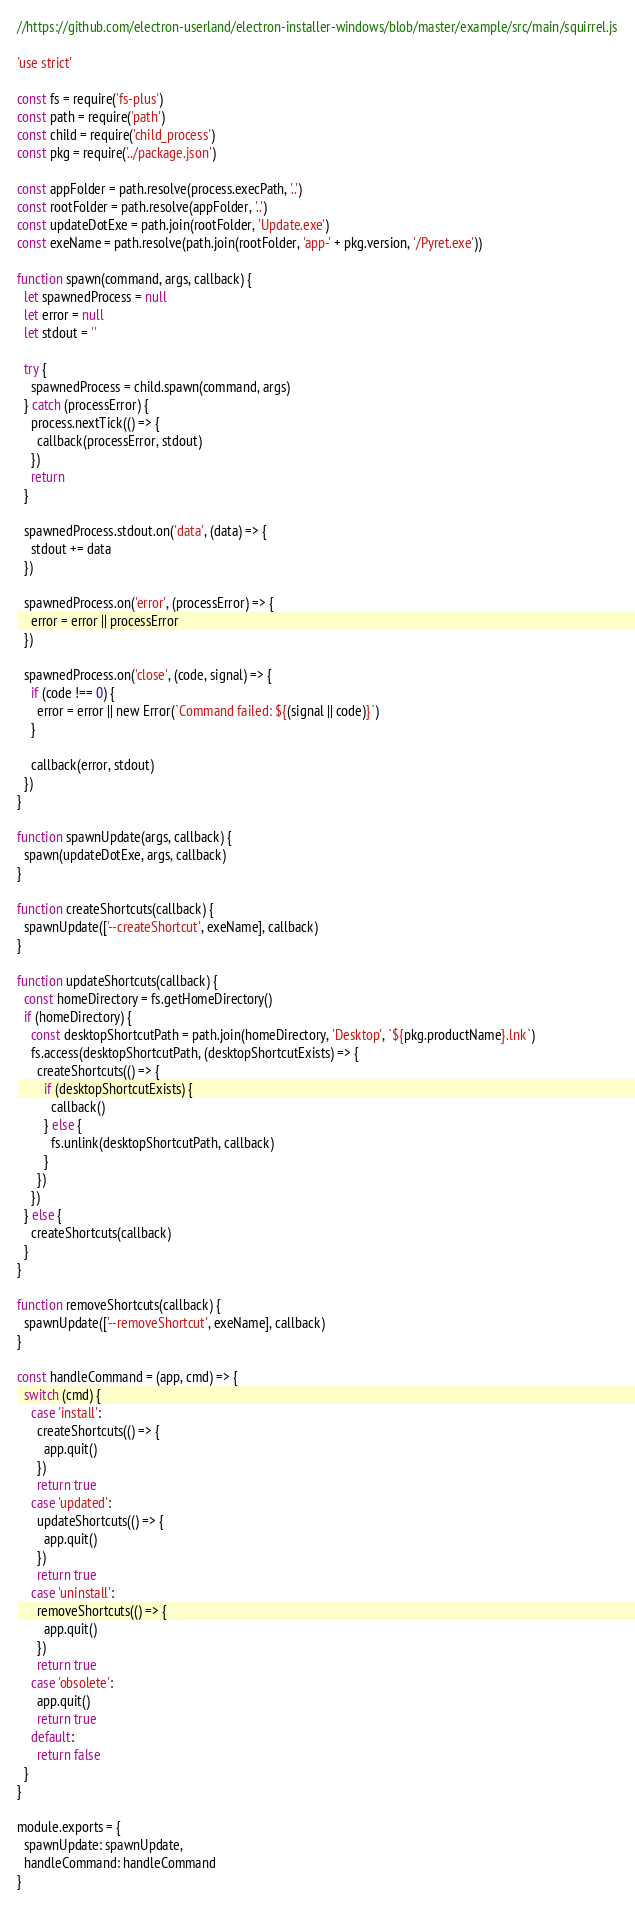Convert code to text. <code><loc_0><loc_0><loc_500><loc_500><_JavaScript_>//https://github.com/electron-userland/electron-installer-windows/blob/master/example/src/main/squirrel.js

'use strict'

const fs = require('fs-plus')
const path = require('path')
const child = require('child_process')
const pkg = require('../package.json')

const appFolder = path.resolve(process.execPath, '..')
const rootFolder = path.resolve(appFolder, '..')
const updateDotExe = path.join(rootFolder, 'Update.exe')
const exeName = path.resolve(path.join(rootFolder, 'app-' + pkg.version, '/Pyret.exe'))

function spawn(command, args, callback) {
  let spawnedProcess = null
  let error = null
  let stdout = ''

  try {
    spawnedProcess = child.spawn(command, args)
  } catch (processError) {
    process.nextTick(() => {
      callback(processError, stdout)
    })
    return
  }

  spawnedProcess.stdout.on('data', (data) => {
    stdout += data
  })

  spawnedProcess.on('error', (processError) => {
    error = error || processError
  })

  spawnedProcess.on('close', (code, signal) => {
    if (code !== 0) {
      error = error || new Error(`Command failed: ${(signal || code)}`)
    }

    callback(error, stdout)
  })
}

function spawnUpdate(args, callback) {
  spawn(updateDotExe, args, callback)
}

function createShortcuts(callback) {
  spawnUpdate(['--createShortcut', exeName], callback)
}

function updateShortcuts(callback) {
  const homeDirectory = fs.getHomeDirectory()
  if (homeDirectory) {
    const desktopShortcutPath = path.join(homeDirectory, 'Desktop', `${pkg.productName}.lnk`)
    fs.access(desktopShortcutPath, (desktopShortcutExists) => {
      createShortcuts(() => {
        if (desktopShortcutExists) {
          callback()
        } else {
          fs.unlink(desktopShortcutPath, callback)
        }
      })
    })
  } else {
    createShortcuts(callback)
  }
}

function removeShortcuts(callback) {
  spawnUpdate(['--removeShortcut', exeName], callback)
}

const handleCommand = (app, cmd) => {
  switch (cmd) {
    case 'install':
      createShortcuts(() => {
        app.quit()
      })
      return true
    case 'updated':
      updateShortcuts(() => {
        app.quit()
      })
      return true
    case 'uninstall':
      removeShortcuts(() => {
        app.quit()
      })
      return true
    case 'obsolete':
      app.quit()
      return true
    default:
      return false
  }
}

module.exports = {
  spawnUpdate: spawnUpdate,
  handleCommand: handleCommand
}
</code> 